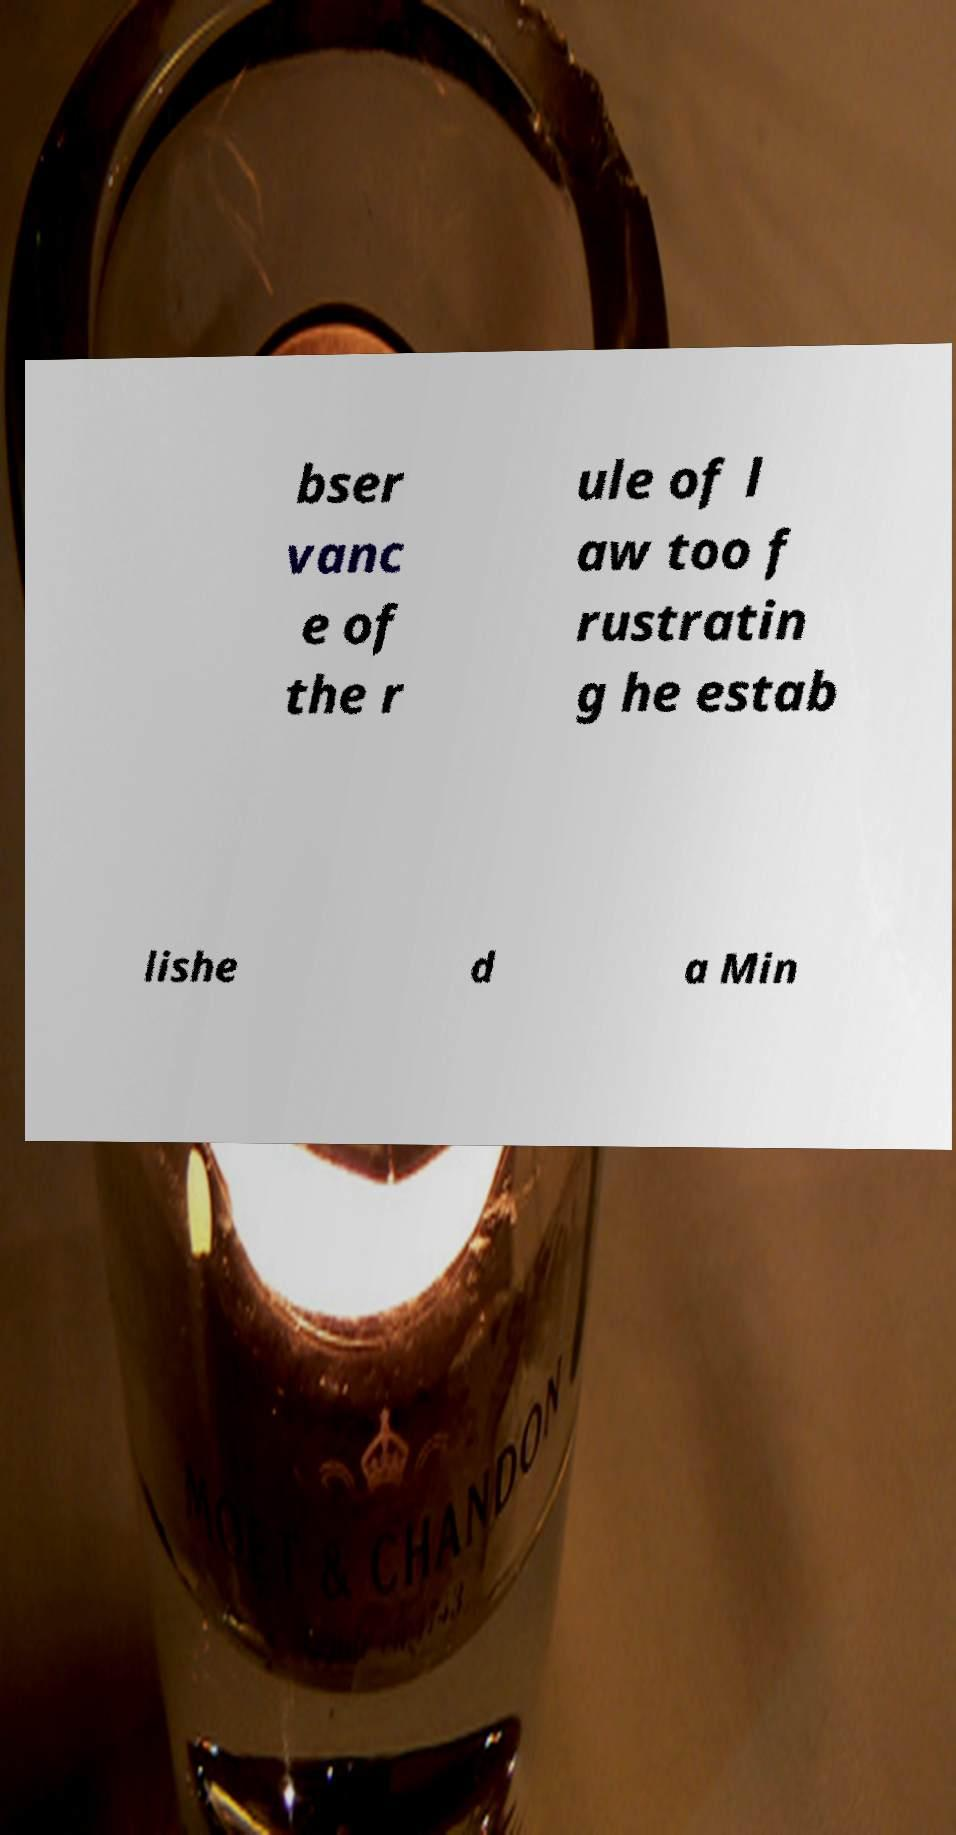Could you assist in decoding the text presented in this image and type it out clearly? bser vanc e of the r ule of l aw too f rustratin g he estab lishe d a Min 